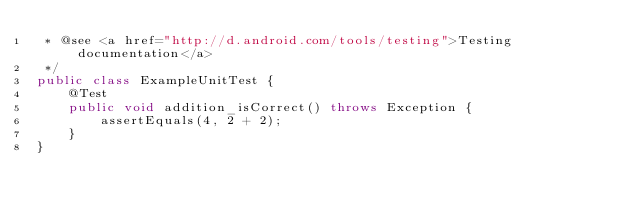Convert code to text. <code><loc_0><loc_0><loc_500><loc_500><_Java_> * @see <a href="http://d.android.com/tools/testing">Testing documentation</a>
 */
public class ExampleUnitTest {
    @Test
    public void addition_isCorrect() throws Exception {
        assertEquals(4, 2 + 2);
    }
}</code> 